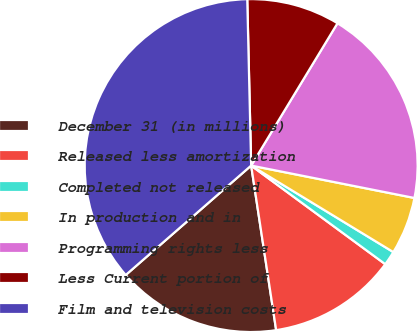Convert chart. <chart><loc_0><loc_0><loc_500><loc_500><pie_chart><fcel>December 31 (in millions)<fcel>Released less amortization<fcel>Completed not released<fcel>In production and in<fcel>Programming rights less<fcel>Less Current portion of<fcel>Film and television costs<nl><fcel>15.98%<fcel>12.51%<fcel>1.39%<fcel>5.58%<fcel>19.44%<fcel>9.05%<fcel>36.04%<nl></chart> 